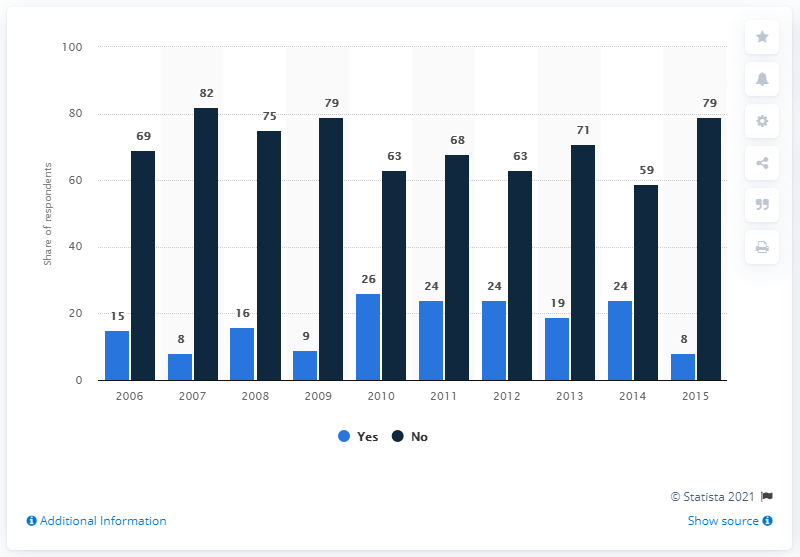Indicate a few pertinent items in this graphic. In 2015, a significant portion of Ukrainians, 79%, expressed lack of confidence in their government. 